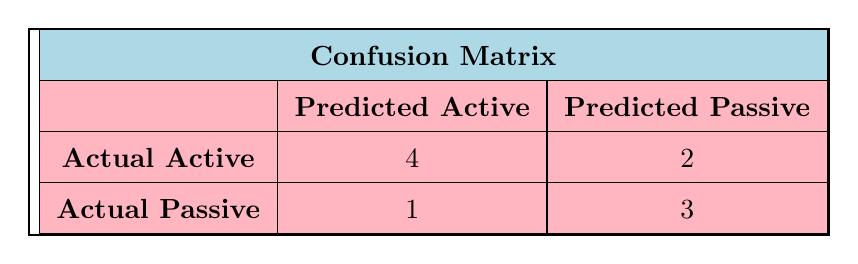What is the total number of Active responses? In the confusion matrix, we look at the row for Actual Active, where the count for Predicted Active is 4. So, there are 4 Active responses.
Answer: 4 How many Passive responses were predicted incorrectly as Active? From the Actual Passive row, we see that there are 1 responses predicted as Active. Therefore, there is 1 Passive response predicted incorrectly as Active.
Answer: 1 What is the total number of responses categorized as Passive? To find the total number of Passive responses, we add both the predicted and actual values in the Passive categories. From the Actual Passive row, there are 1 (Predicted Active) + 3 (Predicted Passive) = 4 Passive responses in total.
Answer: 4 How many total responses were predicted as Active? We look at both rows. From Actual Active, we see there are 4 (Predicted Active) + 2 (Predicted Passive) = 6 Active responses predicted. Thus, the total number of responses predicted as Active is 6.
Answer: 6 Is it true that more responses were predicted as Passive than Active? To evaluate this, we count the responses predicted as Passive: from Actual Active (2) and Actual Passive (3), the total is 2 (from Active) + 3 (from Passive) = 5 predicted as Passive. Since 5 is greater than the 6 predicted as Active, the statement is false.
Answer: No How many more Active responses were correctly predicted than Passive responses? The Active responses predicted correctly from Actual Active are 4, while the Passive responses predicted correctly, taken from Actual Passive are 3. Therefore, the difference is 4 - 3 = 1 more Active response correctly predicted than Passive response.
Answer: 1 What is the accuracy of the predictions based on the confusion matrix? To calculate accuracy, we need the sum of correctly predicted responses divided by the total predictions. The correct predictions are 4 (from Actual Active) + 3 (from Actual Passive) = 7. The total responses are 10. Thus, accuracy = 7/10 = 0.7 or 70%.
Answer: 70% What percentage of the Active predictions were actually Passive? To find this, we refer to the Actual Active row where 2 predictions were actually Passive out of the total predictions for Active (4 Active + 2 Passive = 6). The percentage is (2/6) * 100, which equals approximately 33.33%.
Answer: 33.33% Was the prediction accuracy higher for Passive responses compared to Active responses? The accuracy for Active predictions is 4 out of 6, giving an accuracy of roughly 66.67%, while Passive predictions have 3 out of 4, resulting in 75%. Since 75% is greater than 66.67%, the prediction accuracy for Passive responses is higher.
Answer: Yes 